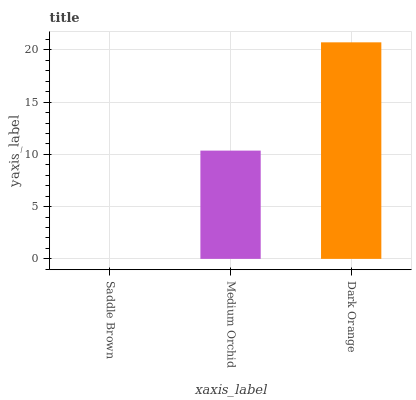Is Saddle Brown the minimum?
Answer yes or no. Yes. Is Dark Orange the maximum?
Answer yes or no. Yes. Is Medium Orchid the minimum?
Answer yes or no. No. Is Medium Orchid the maximum?
Answer yes or no. No. Is Medium Orchid greater than Saddle Brown?
Answer yes or no. Yes. Is Saddle Brown less than Medium Orchid?
Answer yes or no. Yes. Is Saddle Brown greater than Medium Orchid?
Answer yes or no. No. Is Medium Orchid less than Saddle Brown?
Answer yes or no. No. Is Medium Orchid the high median?
Answer yes or no. Yes. Is Medium Orchid the low median?
Answer yes or no. Yes. Is Saddle Brown the high median?
Answer yes or no. No. Is Saddle Brown the low median?
Answer yes or no. No. 